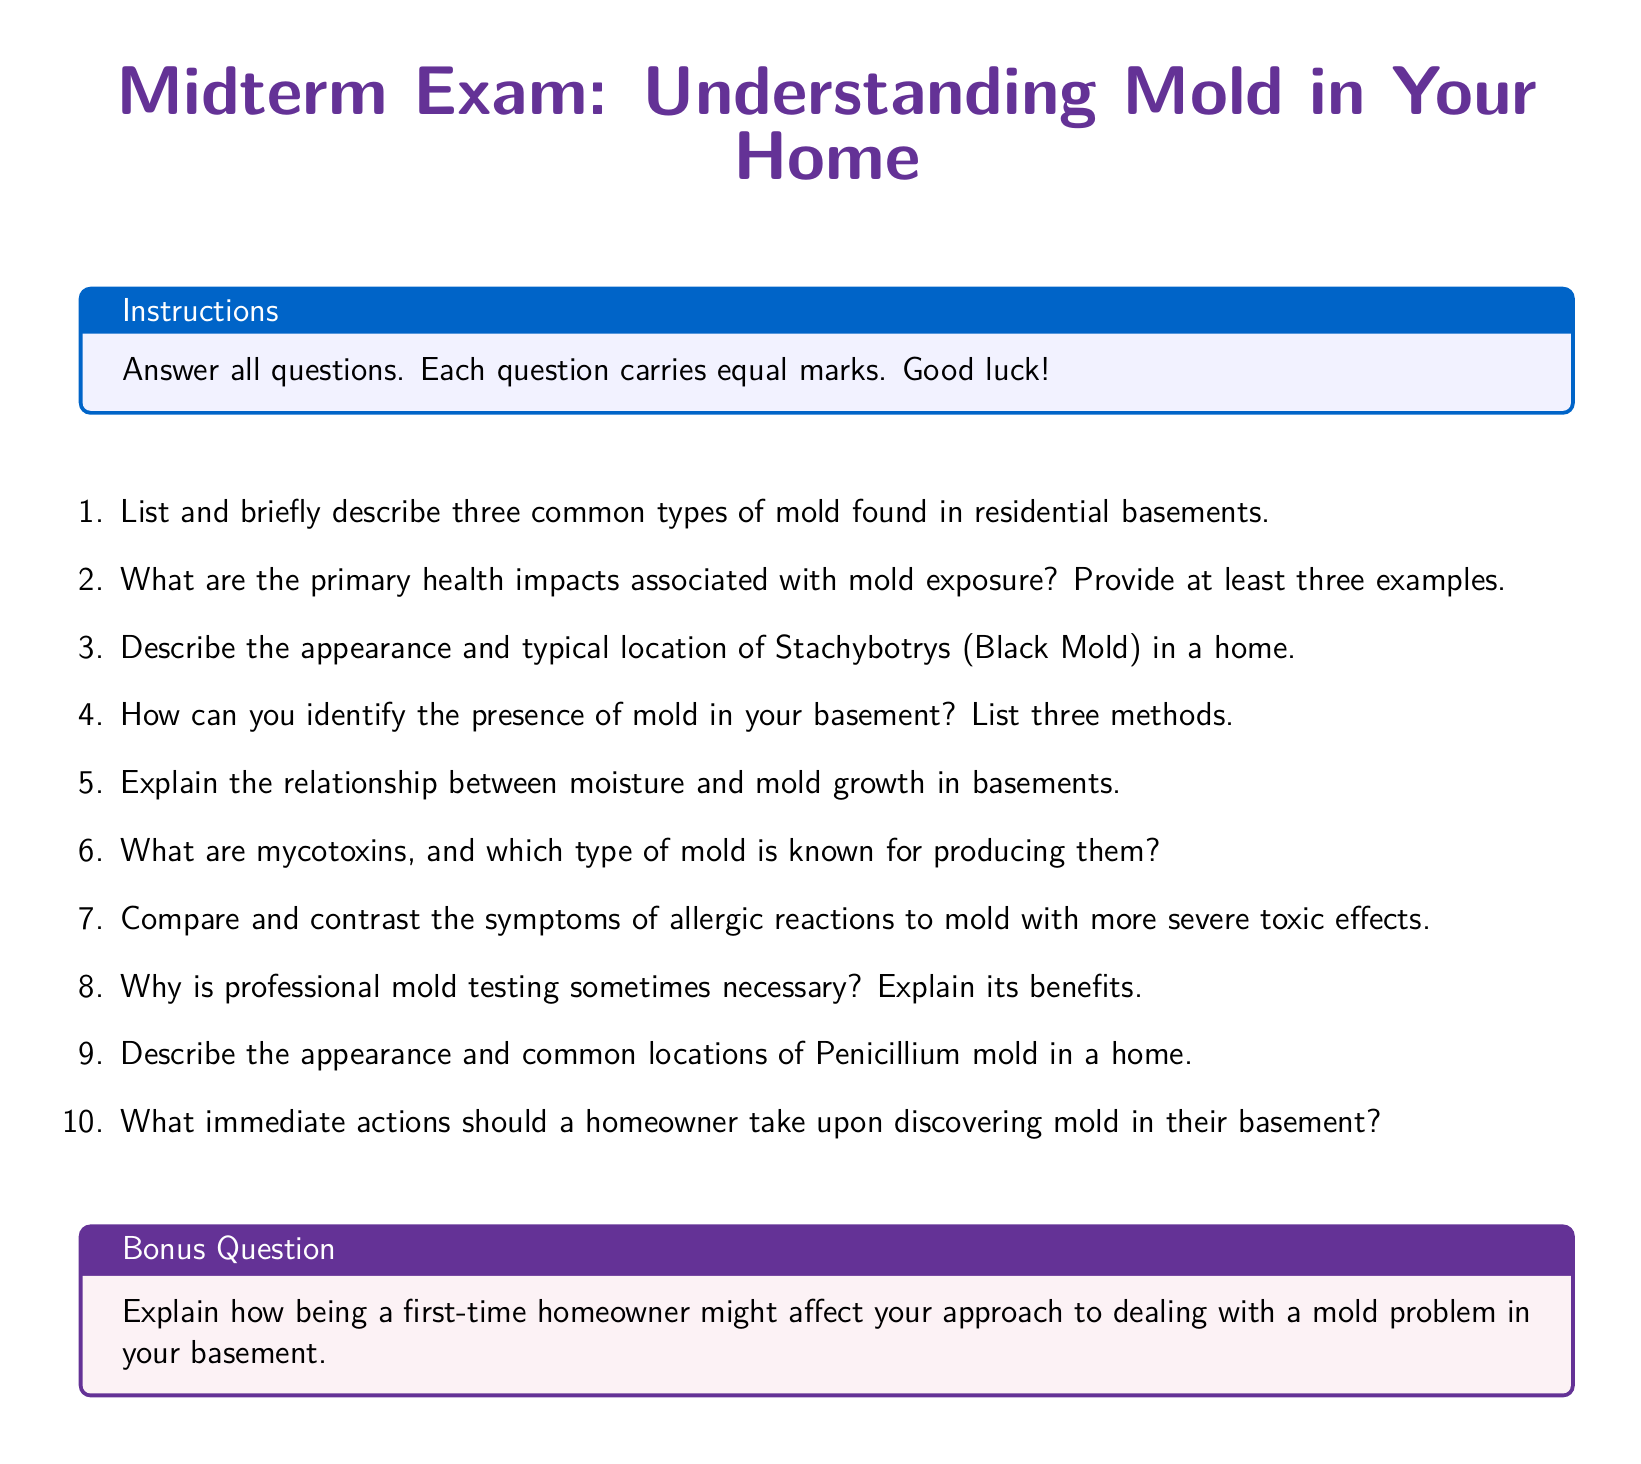What are two common types of mold found in residential basements? The document states that it describes three common types of mold, implying diverse types.
Answer: Stachybotrys, Penicillium What are the primary health impacts associated with mold exposure? The document specifies that at least three examples should be provided regarding health impacts.
Answer: Allergic reactions, respiratory issues, infections How is Stachybotrys (Black Mold) typically described? The document asks for a description of the appearance and location of Stachybotrys in a home.
Answer: Dark green or black color, found in damp areas What is one method to identify mold presence in your basement? The document lists three methods for identifying mold, indicating a need for concrete examples.
Answer: Visual inspection What role does moisture play in mold growth? The document requests an explanation of the relationship between moisture and mold growth.
Answer: Promotes mold growth What are mycotoxins? A question focusing on the document's request for an explanation of mycotoxins and the mold type producing them.
Answer: Toxic compounds from certain molds How should allergic reactions to mold symptoms differ from toxic effects? The document suggests comparing and contrasting symptoms related to mold exposure.
Answer: Allergic reactions are mild; toxic effects are severe What immediate action should be taken upon discovering mold? The document refers to actions homeowners should take upon discovering mold.
Answer: Contain the mold area What is the overall purpose of this document? The midterm exam format implies it assesses understanding related to mold types and health impacts.
Answer: Understanding mold in your home 